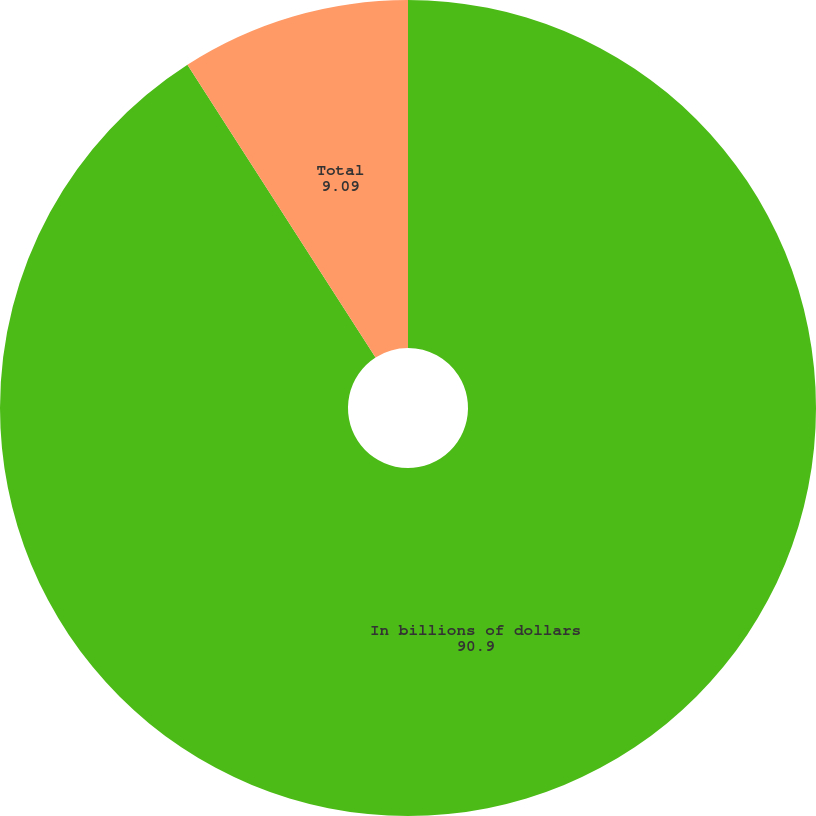Convert chart. <chart><loc_0><loc_0><loc_500><loc_500><pie_chart><fcel>In billions of dollars<fcel>Residential mortgage<fcel>Total<nl><fcel>90.9%<fcel>0.0%<fcel>9.09%<nl></chart> 